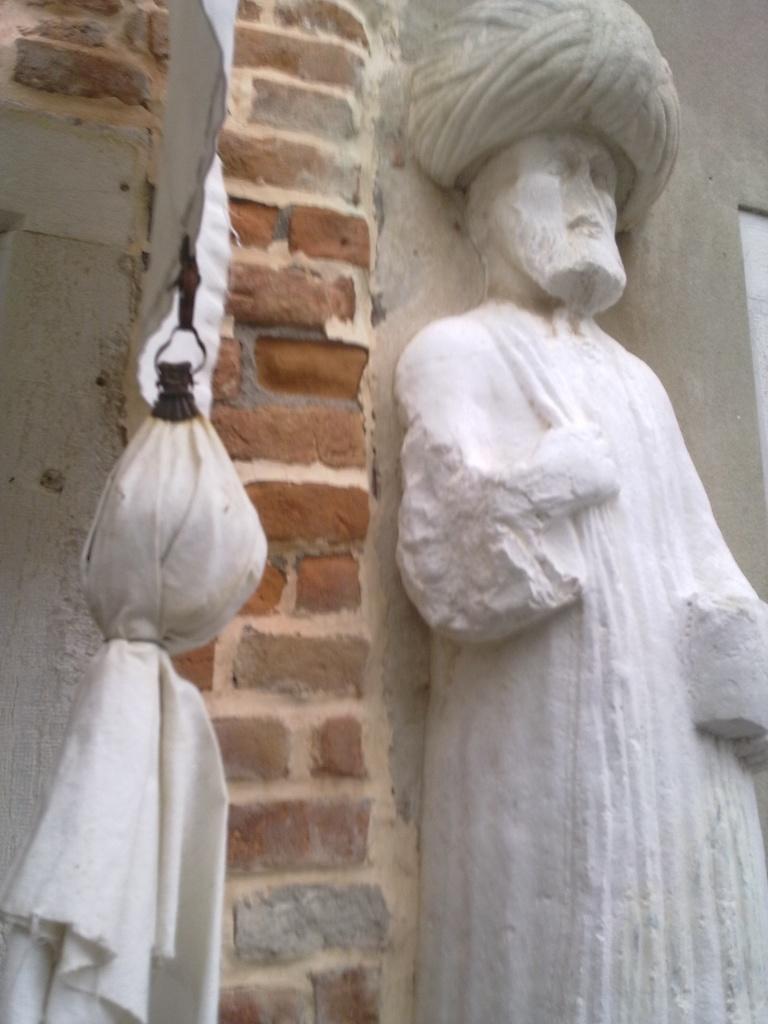Please provide a concise description of this image. In this image I can see the person statue, wall and the white color cloth in front. 